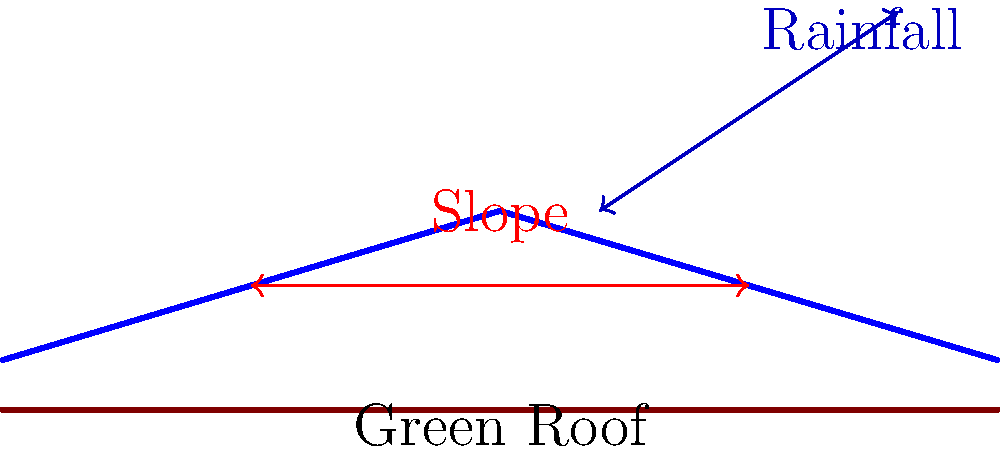As a retired artist designing your log cabin studio, you want to incorporate a green roof. Given that the annual rainfall in your area is 1000 mm and the roof width is 6 meters, what is the optimal slope angle $\theta$ for the green roof to ensure proper drainage while maintaining soil stability? To determine the optimal slope for a green roof, we need to consider both drainage and soil stability. Here's a step-by-step approach:

1. Green roofs typically require a minimum slope of 2% (1.15°) for proper drainage and a maximum of 30% (16.7°) to prevent soil erosion.

2. For areas with high rainfall (>800 mm/year), a steeper slope is recommended. Given the annual rainfall of 1000 mm, we should aim for the upper half of this range.

3. A general rule of thumb for green roofs is:
   - Low rainfall (<600 mm/year): 2-5% slope (1.15°-2.86°)
   - Moderate rainfall (600-800 mm/year): 5-10% slope (2.86°-5.71°)
   - High rainfall (>800 mm/year): 10-30% slope (5.71°-16.7°)

4. Considering the high rainfall, we should aim for a slope between 15-20% (8.53°-11.31°).

5. To calculate the slope angle $\theta$:
   $\tan(\theta) = \frac{\text{rise}}{\text{run}}$

6. For a 6-meter wide roof with a 15% slope:
   $\text{rise} = 6 \text{ m} \times 0.15 = 0.9 \text{ m}$
   $\theta = \arctan(\frac{0.9}{6}) \approx 8.53°$

7. For a 20% slope:
   $\text{rise} = 6 \text{ m} \times 0.20 = 1.2 \text{ m}$
   $\theta = \arctan(\frac{1.2}{6}) \approx 11.31°$

Therefore, the optimal slope angle $\theta$ for the green roof should be between 8.53° and 11.31°.
Answer: 8.53° to 11.31° 